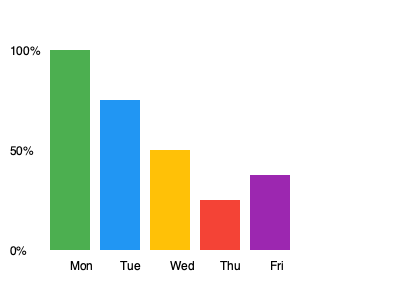As the vice principal analyzing student attendance data, you notice a pattern in the weekly attendance rates. What is the difference between the highest and lowest attendance rates, and on which days did they occur? To solve this question, we need to follow these steps:

1. Identify the highest attendance rate:
   The tallest bar represents Monday with 100% attendance.

2. Identify the lowest attendance rate:
   The shortest bar represents Thursday with 25% attendance.

3. Calculate the difference:
   $100\% - 25\% = 75\%$

4. Determine the days:
   Highest: Monday
   Lowest: Thursday

Therefore, the difference between the highest and lowest attendance rates is 75%, occurring on Monday (highest) and Thursday (lowest).
Answer: 75%; Monday and Thursday 